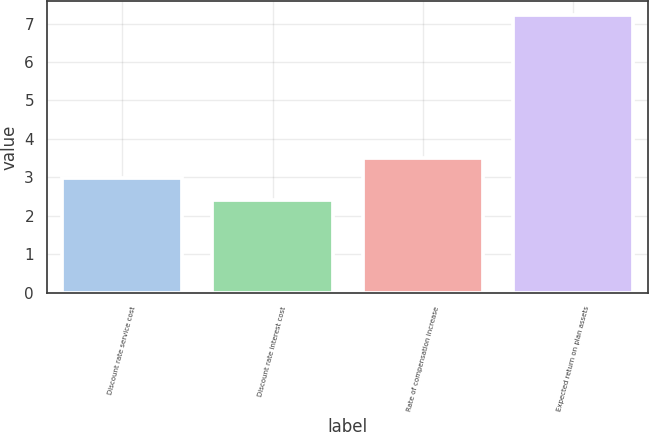Convert chart to OTSL. <chart><loc_0><loc_0><loc_500><loc_500><bar_chart><fcel>Discount rate service cost<fcel>Discount rate interest cost<fcel>Rate of compensation increase<fcel>Expected return on plan assets<nl><fcel>2.99<fcel>2.41<fcel>3.5<fcel>7.22<nl></chart> 